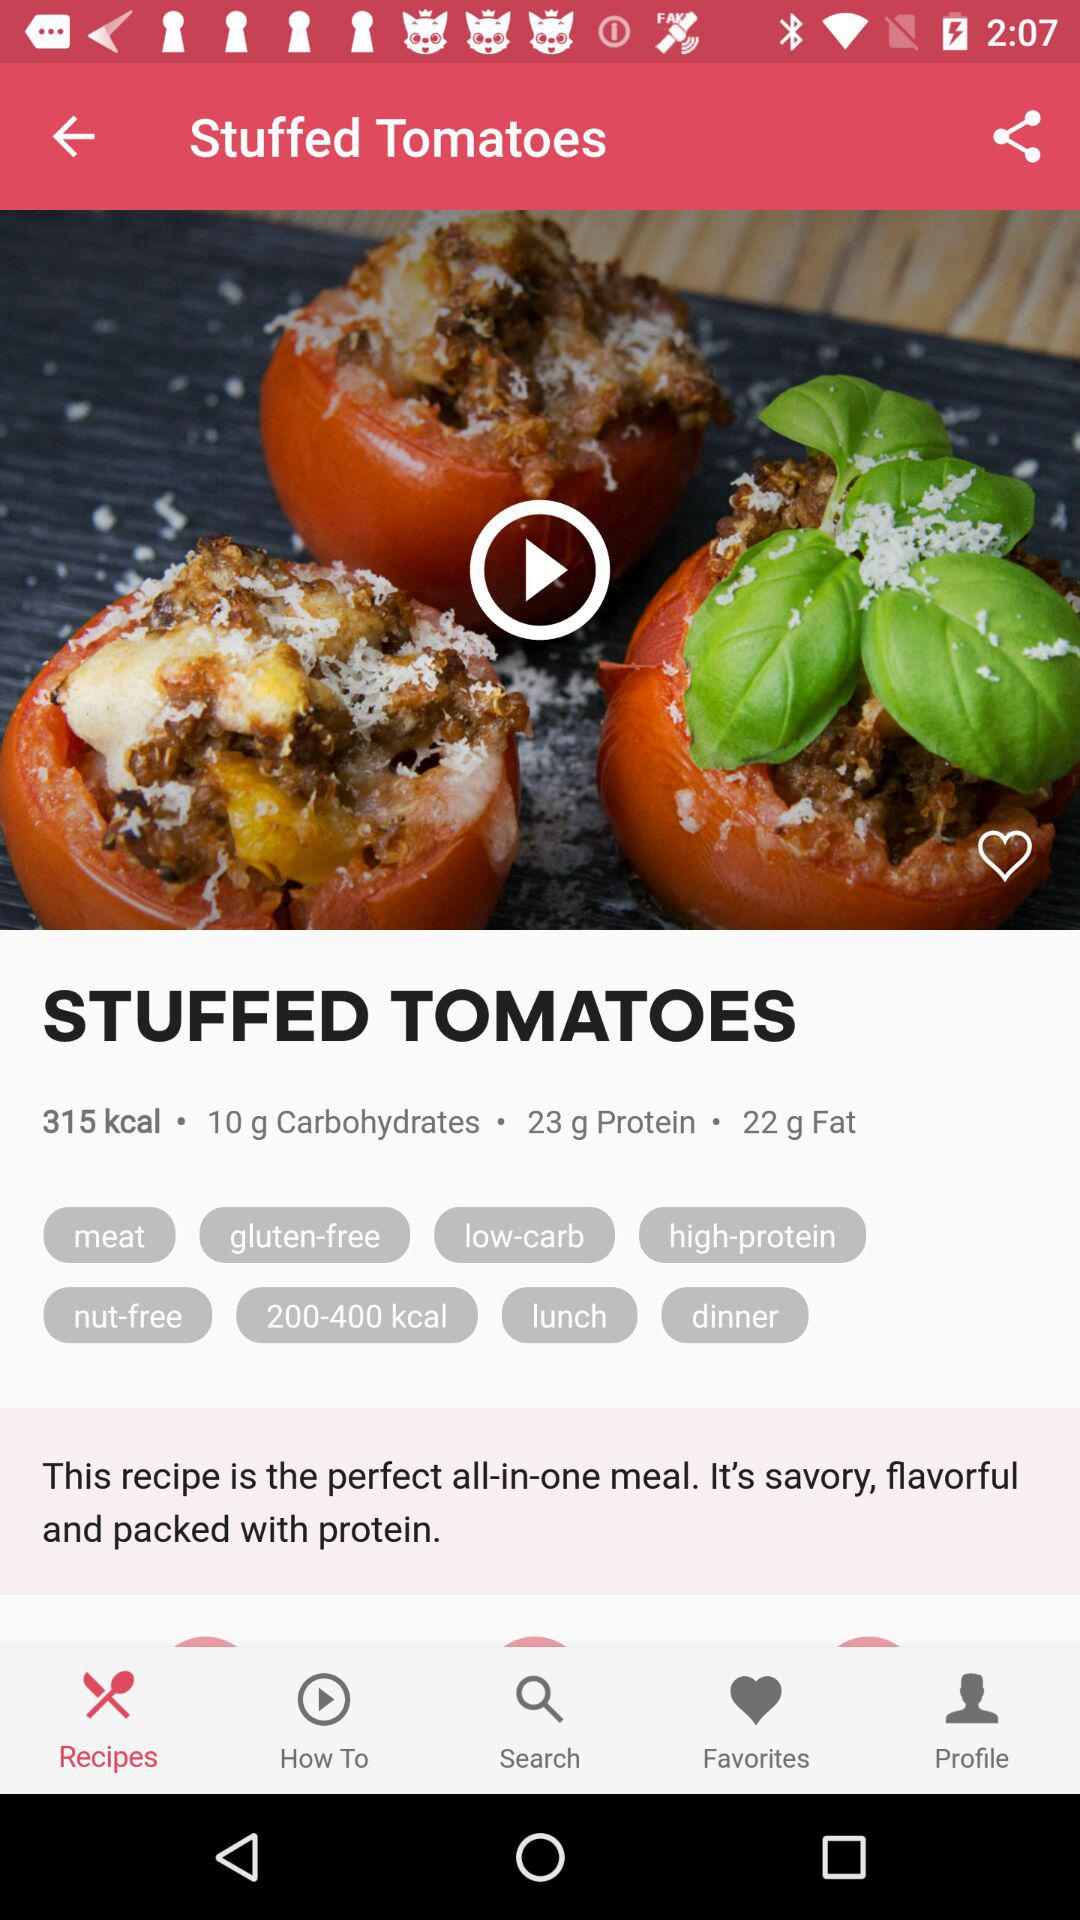How many carbohydrates are in the "STUFFED TOMATOES" dish? There are 10 grams of carbohydrates in the "STUFFED TOMATOES" dish. 